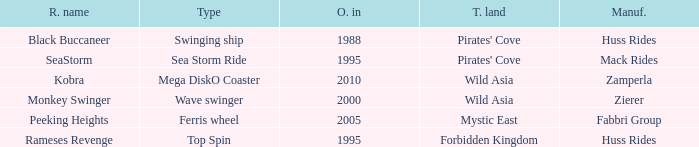Which ride opened after the 2000 Peeking Heights? Ferris wheel. 